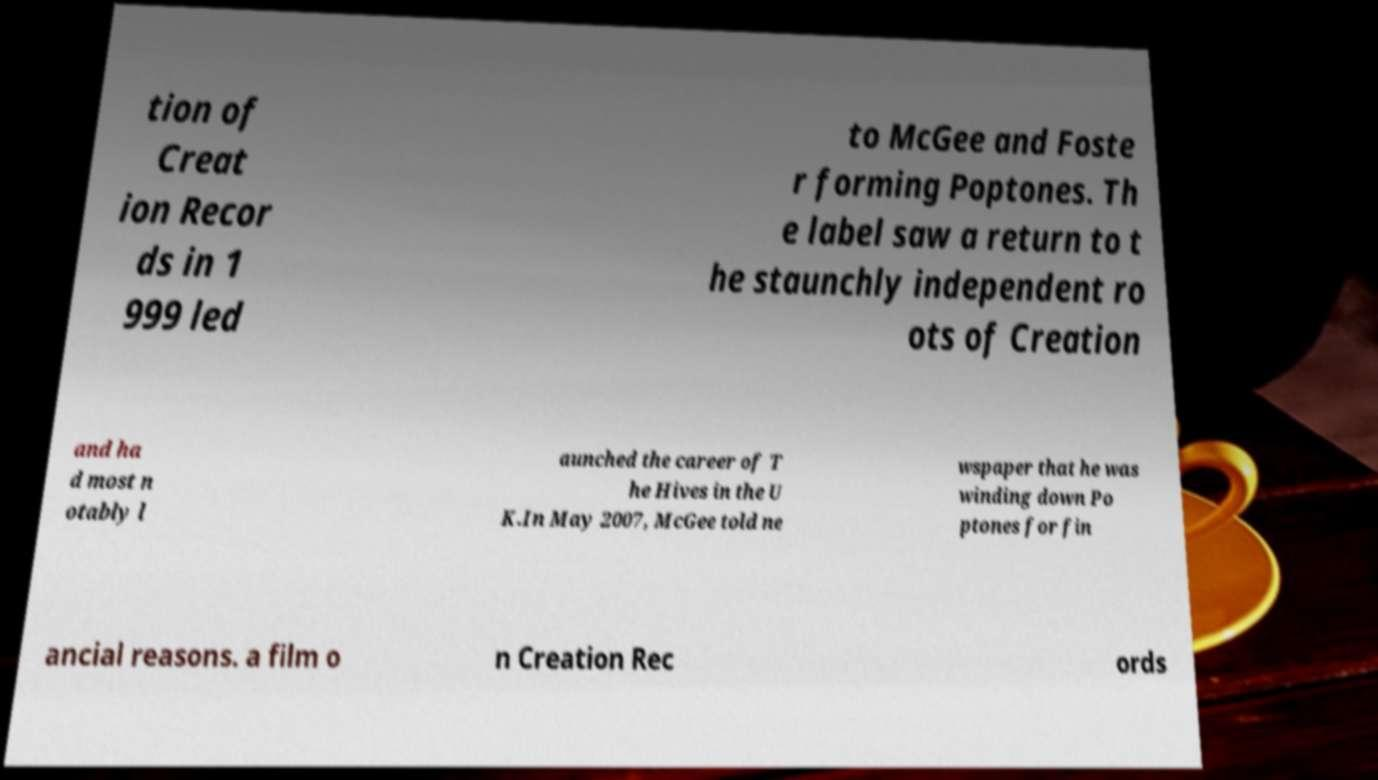Could you assist in decoding the text presented in this image and type it out clearly? tion of Creat ion Recor ds in 1 999 led to McGee and Foste r forming Poptones. Th e label saw a return to t he staunchly independent ro ots of Creation and ha d most n otably l aunched the career of T he Hives in the U K.In May 2007, McGee told ne wspaper that he was winding down Po ptones for fin ancial reasons. a film o n Creation Rec ords 